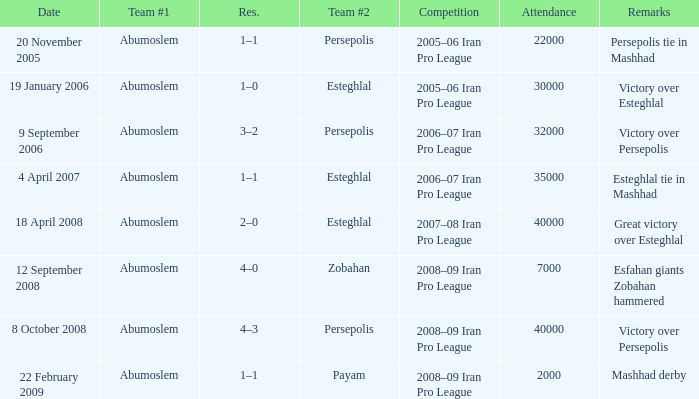What was the res for the game against Payam? 1–1. 